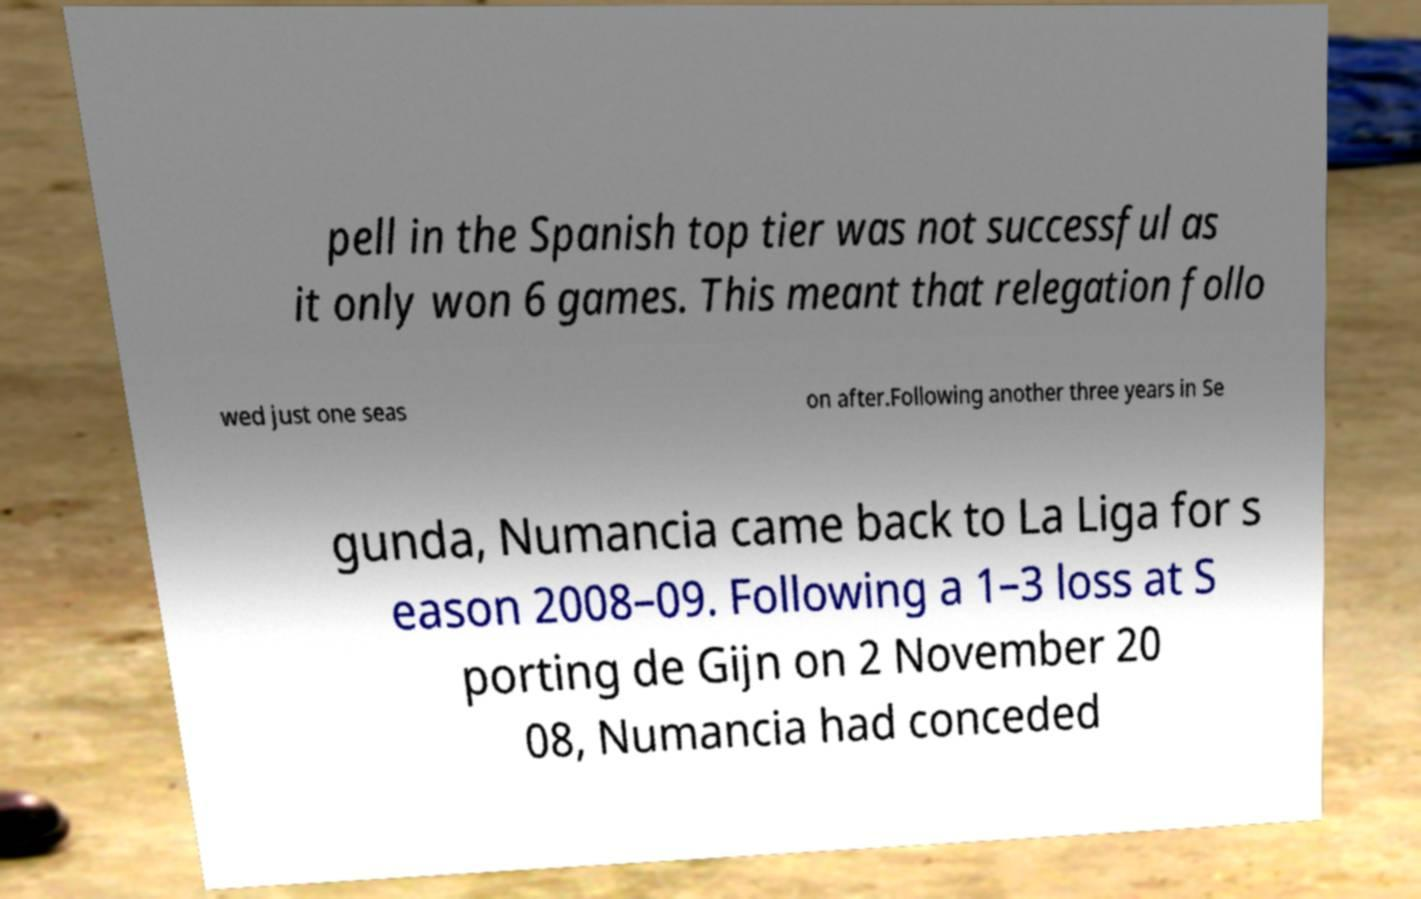Please read and relay the text visible in this image. What does it say? pell in the Spanish top tier was not successful as it only won 6 games. This meant that relegation follo wed just one seas on after.Following another three years in Se gunda, Numancia came back to La Liga for s eason 2008–09. Following a 1–3 loss at S porting de Gijn on 2 November 20 08, Numancia had conceded 